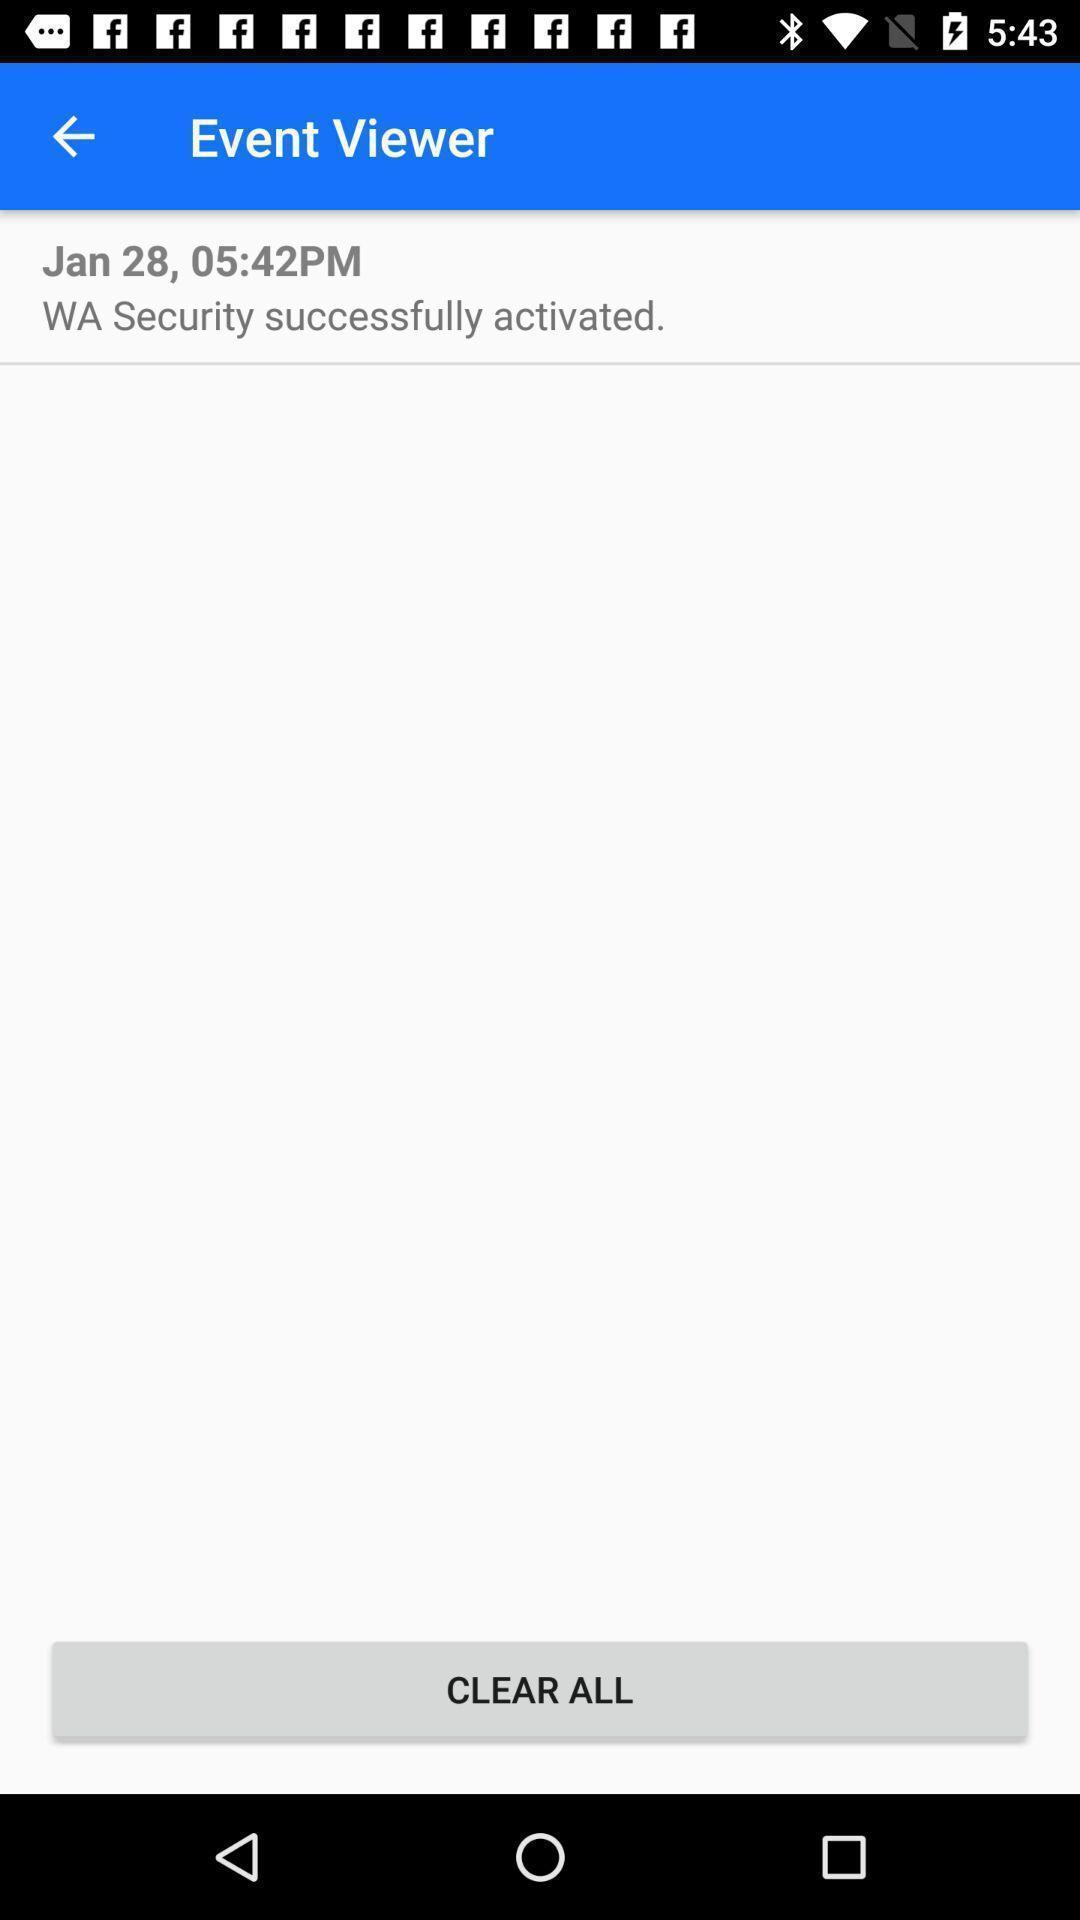Tell me what you see in this picture. Screen showing event viewer. 